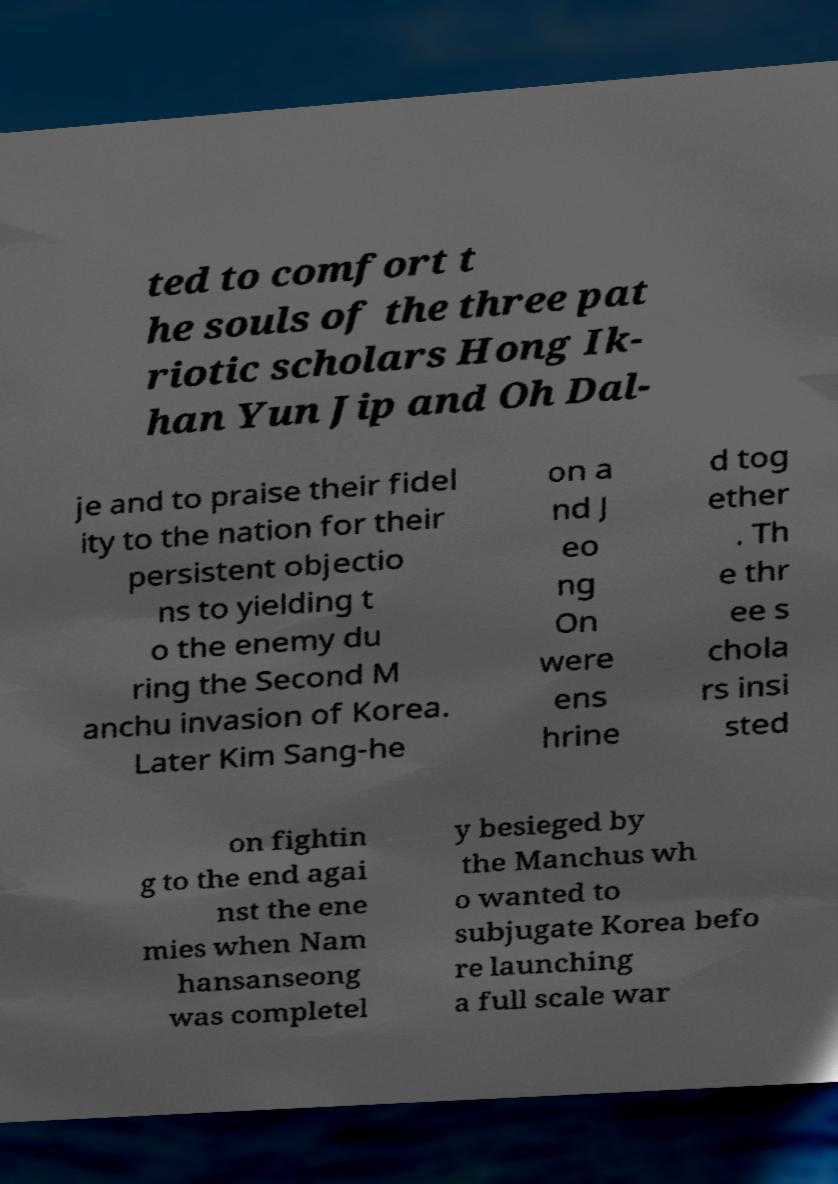Please identify and transcribe the text found in this image. ted to comfort t he souls of the three pat riotic scholars Hong Ik- han Yun Jip and Oh Dal- je and to praise their fidel ity to the nation for their persistent objectio ns to yielding t o the enemy du ring the Second M anchu invasion of Korea. Later Kim Sang-he on a nd J eo ng On were ens hrine d tog ether . Th e thr ee s chola rs insi sted on fightin g to the end agai nst the ene mies when Nam hansanseong was completel y besieged by the Manchus wh o wanted to subjugate Korea befo re launching a full scale war 